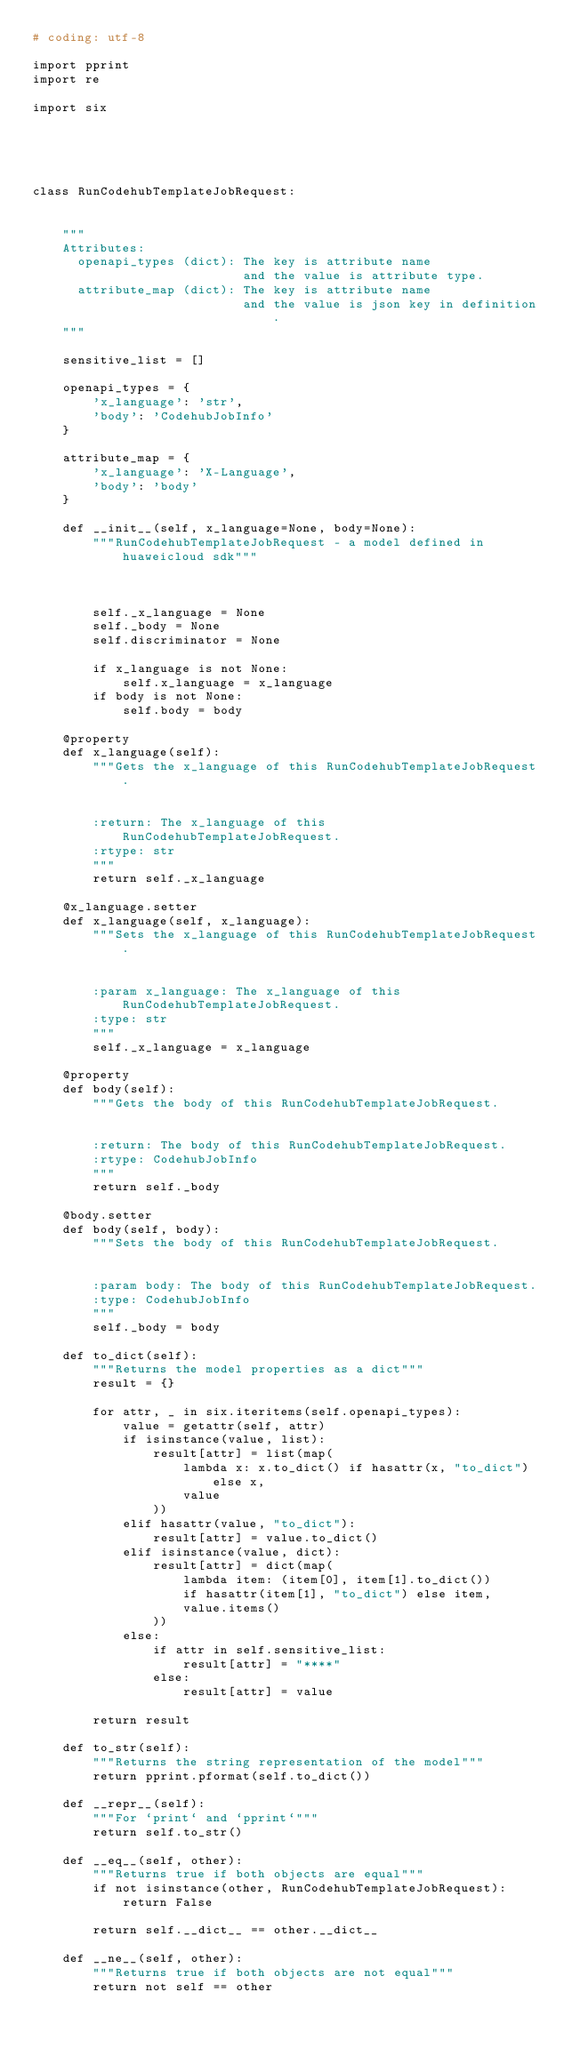<code> <loc_0><loc_0><loc_500><loc_500><_Python_># coding: utf-8

import pprint
import re

import six





class RunCodehubTemplateJobRequest:


    """
    Attributes:
      openapi_types (dict): The key is attribute name
                            and the value is attribute type.
      attribute_map (dict): The key is attribute name
                            and the value is json key in definition.
    """

    sensitive_list = []

    openapi_types = {
        'x_language': 'str',
        'body': 'CodehubJobInfo'
    }

    attribute_map = {
        'x_language': 'X-Language',
        'body': 'body'
    }

    def __init__(self, x_language=None, body=None):
        """RunCodehubTemplateJobRequest - a model defined in huaweicloud sdk"""
        
        

        self._x_language = None
        self._body = None
        self.discriminator = None

        if x_language is not None:
            self.x_language = x_language
        if body is not None:
            self.body = body

    @property
    def x_language(self):
        """Gets the x_language of this RunCodehubTemplateJobRequest.


        :return: The x_language of this RunCodehubTemplateJobRequest.
        :rtype: str
        """
        return self._x_language

    @x_language.setter
    def x_language(self, x_language):
        """Sets the x_language of this RunCodehubTemplateJobRequest.


        :param x_language: The x_language of this RunCodehubTemplateJobRequest.
        :type: str
        """
        self._x_language = x_language

    @property
    def body(self):
        """Gets the body of this RunCodehubTemplateJobRequest.


        :return: The body of this RunCodehubTemplateJobRequest.
        :rtype: CodehubJobInfo
        """
        return self._body

    @body.setter
    def body(self, body):
        """Sets the body of this RunCodehubTemplateJobRequest.


        :param body: The body of this RunCodehubTemplateJobRequest.
        :type: CodehubJobInfo
        """
        self._body = body

    def to_dict(self):
        """Returns the model properties as a dict"""
        result = {}

        for attr, _ in six.iteritems(self.openapi_types):
            value = getattr(self, attr)
            if isinstance(value, list):
                result[attr] = list(map(
                    lambda x: x.to_dict() if hasattr(x, "to_dict") else x,
                    value
                ))
            elif hasattr(value, "to_dict"):
                result[attr] = value.to_dict()
            elif isinstance(value, dict):
                result[attr] = dict(map(
                    lambda item: (item[0], item[1].to_dict())
                    if hasattr(item[1], "to_dict") else item,
                    value.items()
                ))
            else:
                if attr in self.sensitive_list:
                    result[attr] = "****"
                else:
                    result[attr] = value

        return result

    def to_str(self):
        """Returns the string representation of the model"""
        return pprint.pformat(self.to_dict())

    def __repr__(self):
        """For `print` and `pprint`"""
        return self.to_str()

    def __eq__(self, other):
        """Returns true if both objects are equal"""
        if not isinstance(other, RunCodehubTemplateJobRequest):
            return False

        return self.__dict__ == other.__dict__

    def __ne__(self, other):
        """Returns true if both objects are not equal"""
        return not self == other
</code> 